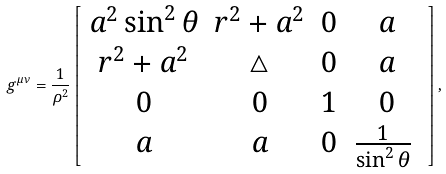Convert formula to latex. <formula><loc_0><loc_0><loc_500><loc_500>g ^ { \mu \nu } = \frac { 1 } { \rho ^ { 2 } } \left [ \begin{array} { c c c c } a ^ { 2 } \sin ^ { 2 } \theta & r ^ { 2 } + a ^ { 2 } & 0 & a \\ r ^ { 2 } + a ^ { 2 } & \triangle & 0 & a \\ 0 & 0 & 1 & 0 \\ a & a & 0 & \frac { 1 } { \sin ^ { 2 } \theta } \ \end{array} \right ] ,</formula> 